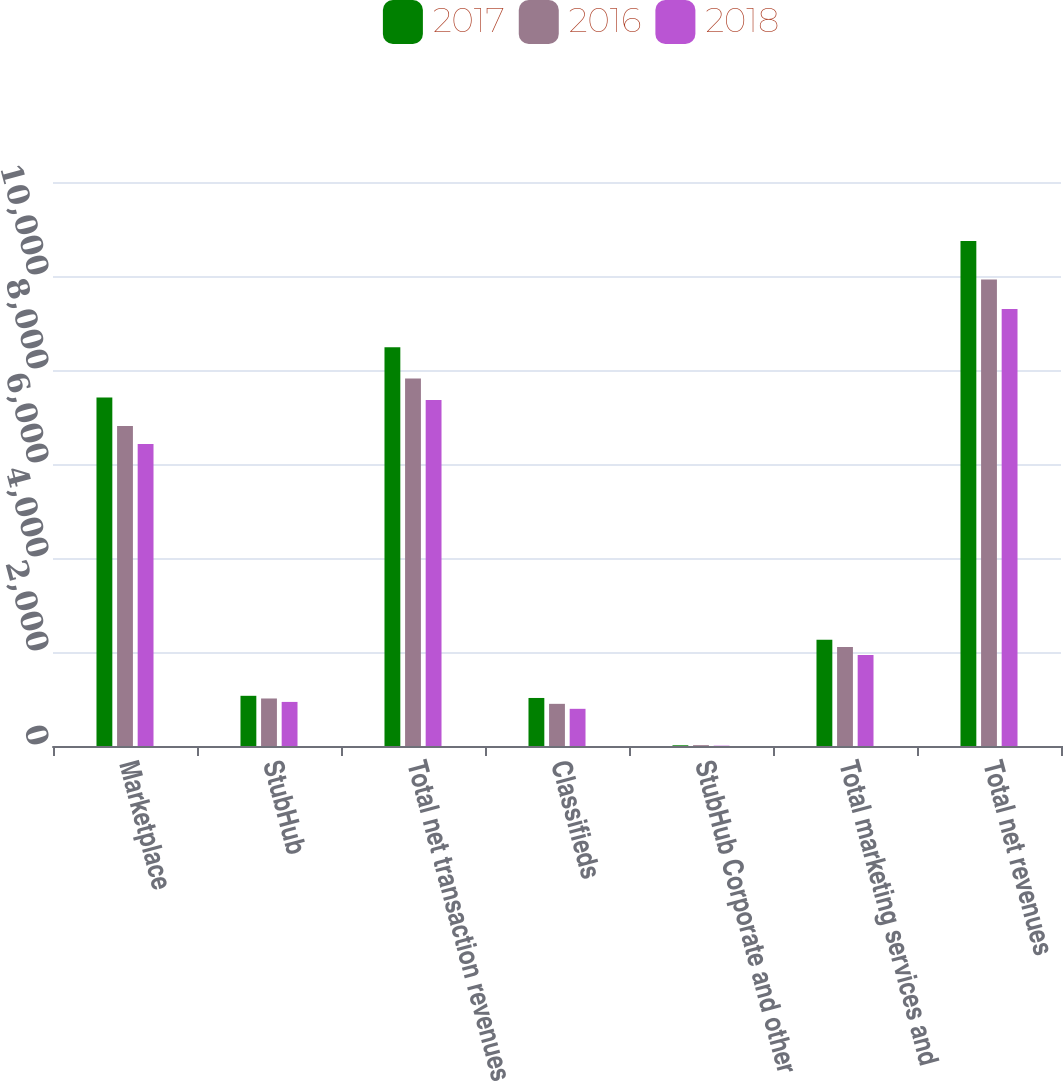Convert chart. <chart><loc_0><loc_0><loc_500><loc_500><stacked_bar_chart><ecel><fcel>Marketplace<fcel>StubHub<fcel>Total net transaction revenues<fcel>Classifieds<fcel>StubHub Corporate and other<fcel>Total marketing services and<fcel>Total net revenues<nl><fcel>2017<fcel>7416<fcel>1068<fcel>8484<fcel>1022<fcel>15<fcel>2262<fcel>10746<nl><fcel>2016<fcel>6809<fcel>1011<fcel>7820<fcel>897<fcel>18<fcel>2107<fcel>9927<nl><fcel>2018<fcel>6425<fcel>938<fcel>7363<fcel>791<fcel>7<fcel>1935<fcel>9298<nl></chart> 